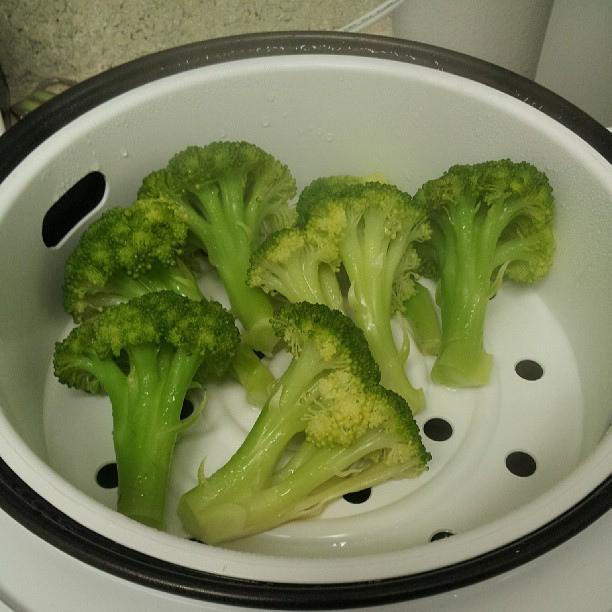What color is the container?
Keep it brief. White. How many pieces of broccoli are there?
Write a very short answer. 6. Are the broccoli steamed?
Answer briefly. Yes. 